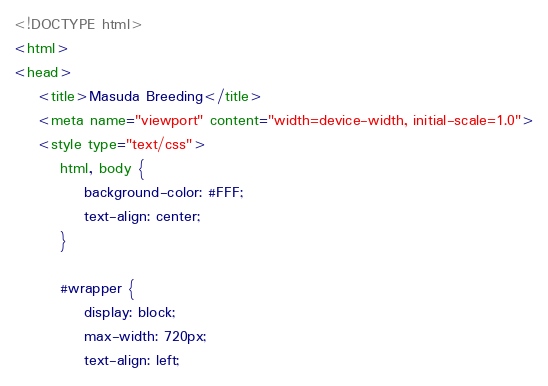<code> <loc_0><loc_0><loc_500><loc_500><_HTML_><!DOCTYPE html>
<html>
<head>
	<title>Masuda Breeding</title>
	<meta name="viewport" content="width=device-width, initial-scale=1.0">
	<style type="text/css">
		html, body {
			background-color: #FFF;
			text-align: center;
		}

		#wrapper {
			display: block;
			max-width: 720px;
			text-align: left;</code> 